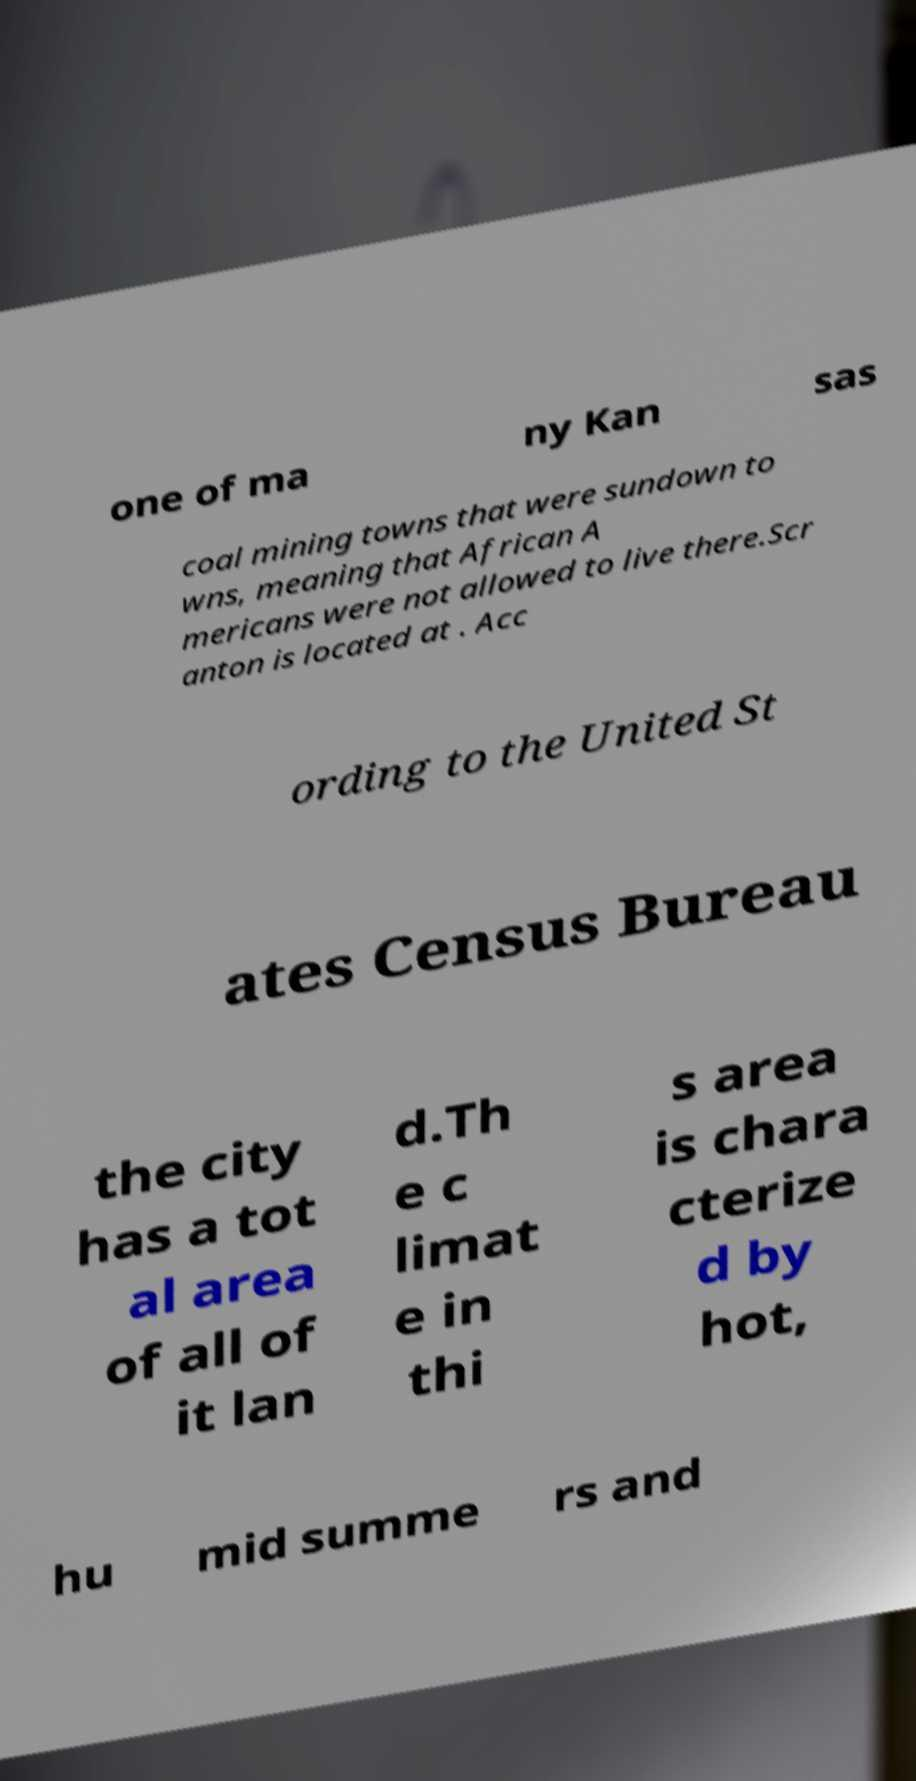Please identify and transcribe the text found in this image. one of ma ny Kan sas coal mining towns that were sundown to wns, meaning that African A mericans were not allowed to live there.Scr anton is located at . Acc ording to the United St ates Census Bureau the city has a tot al area of all of it lan d.Th e c limat e in thi s area is chara cterize d by hot, hu mid summe rs and 